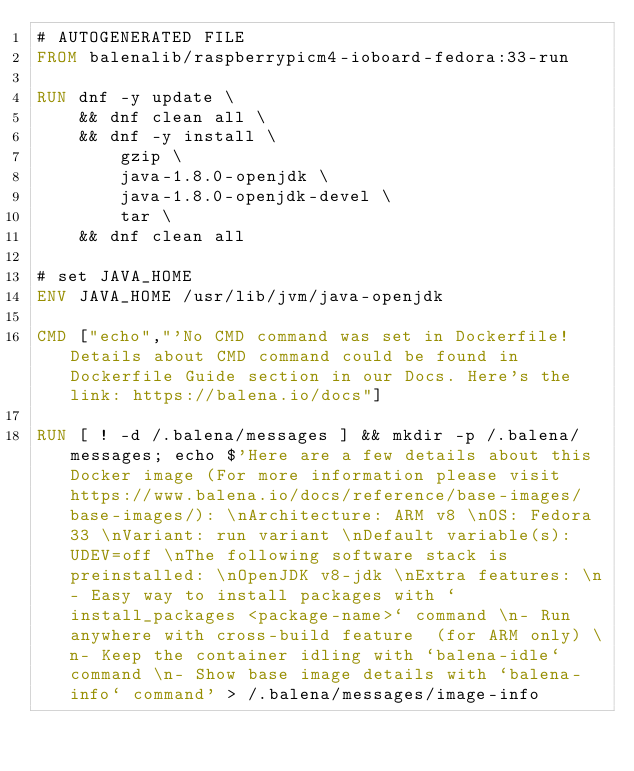<code> <loc_0><loc_0><loc_500><loc_500><_Dockerfile_># AUTOGENERATED FILE
FROM balenalib/raspberrypicm4-ioboard-fedora:33-run

RUN dnf -y update \
	&& dnf clean all \
	&& dnf -y install \
		gzip \
		java-1.8.0-openjdk \
		java-1.8.0-openjdk-devel \
		tar \
	&& dnf clean all

# set JAVA_HOME
ENV JAVA_HOME /usr/lib/jvm/java-openjdk

CMD ["echo","'No CMD command was set in Dockerfile! Details about CMD command could be found in Dockerfile Guide section in our Docs. Here's the link: https://balena.io/docs"]

RUN [ ! -d /.balena/messages ] && mkdir -p /.balena/messages; echo $'Here are a few details about this Docker image (For more information please visit https://www.balena.io/docs/reference/base-images/base-images/): \nArchitecture: ARM v8 \nOS: Fedora 33 \nVariant: run variant \nDefault variable(s): UDEV=off \nThe following software stack is preinstalled: \nOpenJDK v8-jdk \nExtra features: \n- Easy way to install packages with `install_packages <package-name>` command \n- Run anywhere with cross-build feature  (for ARM only) \n- Keep the container idling with `balena-idle` command \n- Show base image details with `balena-info` command' > /.balena/messages/image-info</code> 